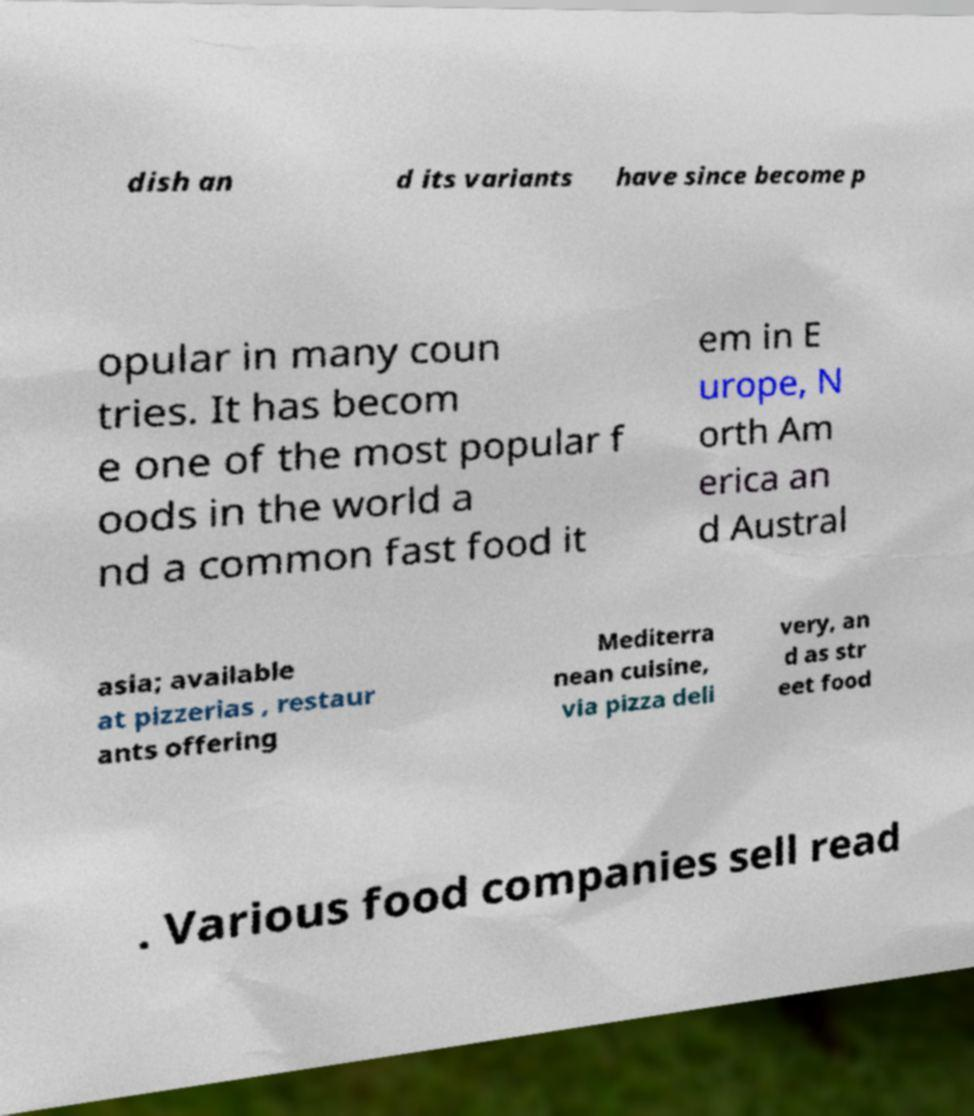Can you read and provide the text displayed in the image?This photo seems to have some interesting text. Can you extract and type it out for me? dish an d its variants have since become p opular in many coun tries. It has becom e one of the most popular f oods in the world a nd a common fast food it em in E urope, N orth Am erica an d Austral asia; available at pizzerias , restaur ants offering Mediterra nean cuisine, via pizza deli very, an d as str eet food . Various food companies sell read 